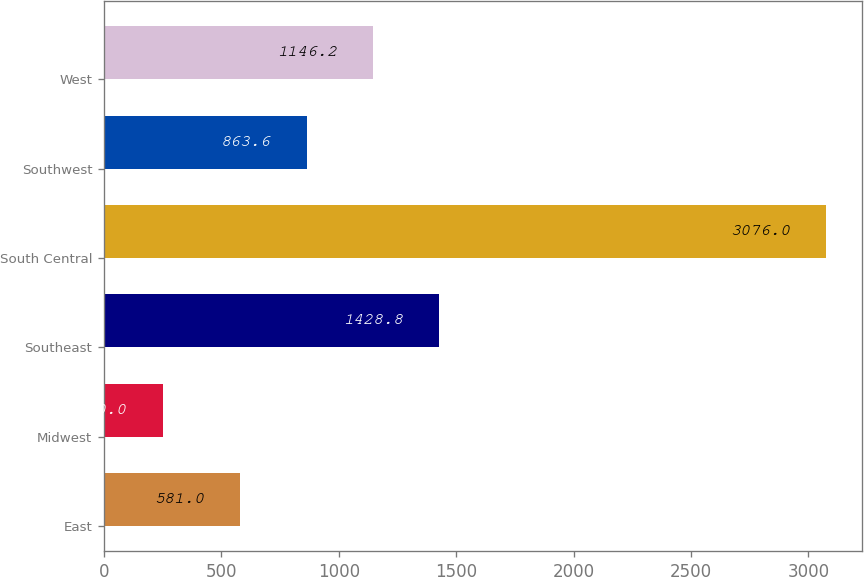Convert chart to OTSL. <chart><loc_0><loc_0><loc_500><loc_500><bar_chart><fcel>East<fcel>Midwest<fcel>Southeast<fcel>South Central<fcel>Southwest<fcel>West<nl><fcel>581<fcel>250<fcel>1428.8<fcel>3076<fcel>863.6<fcel>1146.2<nl></chart> 